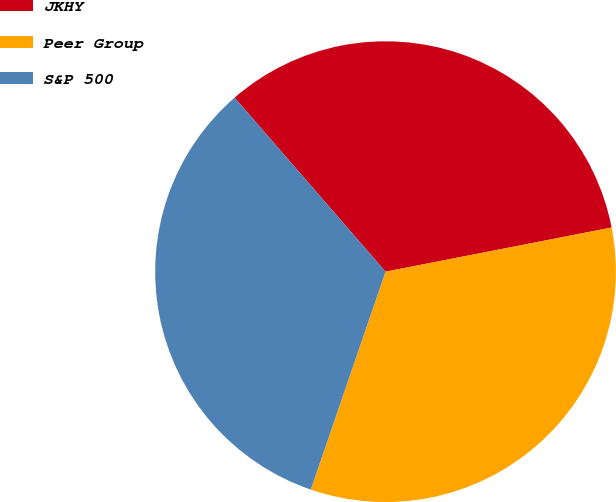Convert chart. <chart><loc_0><loc_0><loc_500><loc_500><pie_chart><fcel>JKHY<fcel>Peer Group<fcel>S&P 500<nl><fcel>33.3%<fcel>33.33%<fcel>33.37%<nl></chart> 